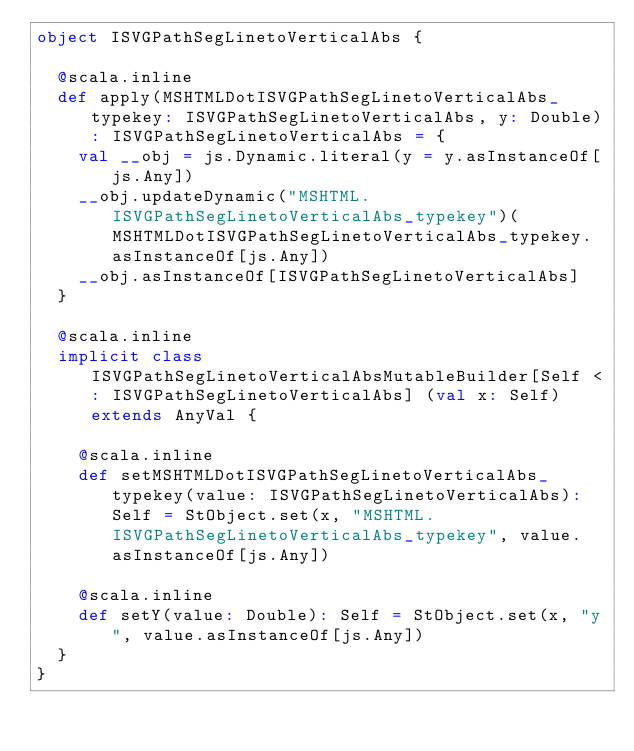Convert code to text. <code><loc_0><loc_0><loc_500><loc_500><_Scala_>object ISVGPathSegLinetoVerticalAbs {
  
  @scala.inline
  def apply(MSHTMLDotISVGPathSegLinetoVerticalAbs_typekey: ISVGPathSegLinetoVerticalAbs, y: Double): ISVGPathSegLinetoVerticalAbs = {
    val __obj = js.Dynamic.literal(y = y.asInstanceOf[js.Any])
    __obj.updateDynamic("MSHTML.ISVGPathSegLinetoVerticalAbs_typekey")(MSHTMLDotISVGPathSegLinetoVerticalAbs_typekey.asInstanceOf[js.Any])
    __obj.asInstanceOf[ISVGPathSegLinetoVerticalAbs]
  }
  
  @scala.inline
  implicit class ISVGPathSegLinetoVerticalAbsMutableBuilder[Self <: ISVGPathSegLinetoVerticalAbs] (val x: Self) extends AnyVal {
    
    @scala.inline
    def setMSHTMLDotISVGPathSegLinetoVerticalAbs_typekey(value: ISVGPathSegLinetoVerticalAbs): Self = StObject.set(x, "MSHTML.ISVGPathSegLinetoVerticalAbs_typekey", value.asInstanceOf[js.Any])
    
    @scala.inline
    def setY(value: Double): Self = StObject.set(x, "y", value.asInstanceOf[js.Any])
  }
}
</code> 